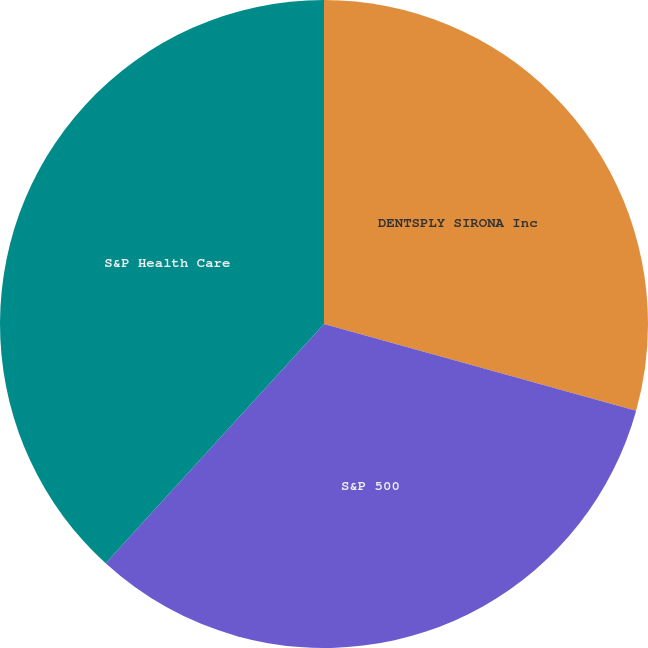<chart> <loc_0><loc_0><loc_500><loc_500><pie_chart><fcel>DENTSPLY SIRONA Inc<fcel>S&P 500<fcel>S&P Health Care<nl><fcel>29.32%<fcel>32.45%<fcel>38.23%<nl></chart> 